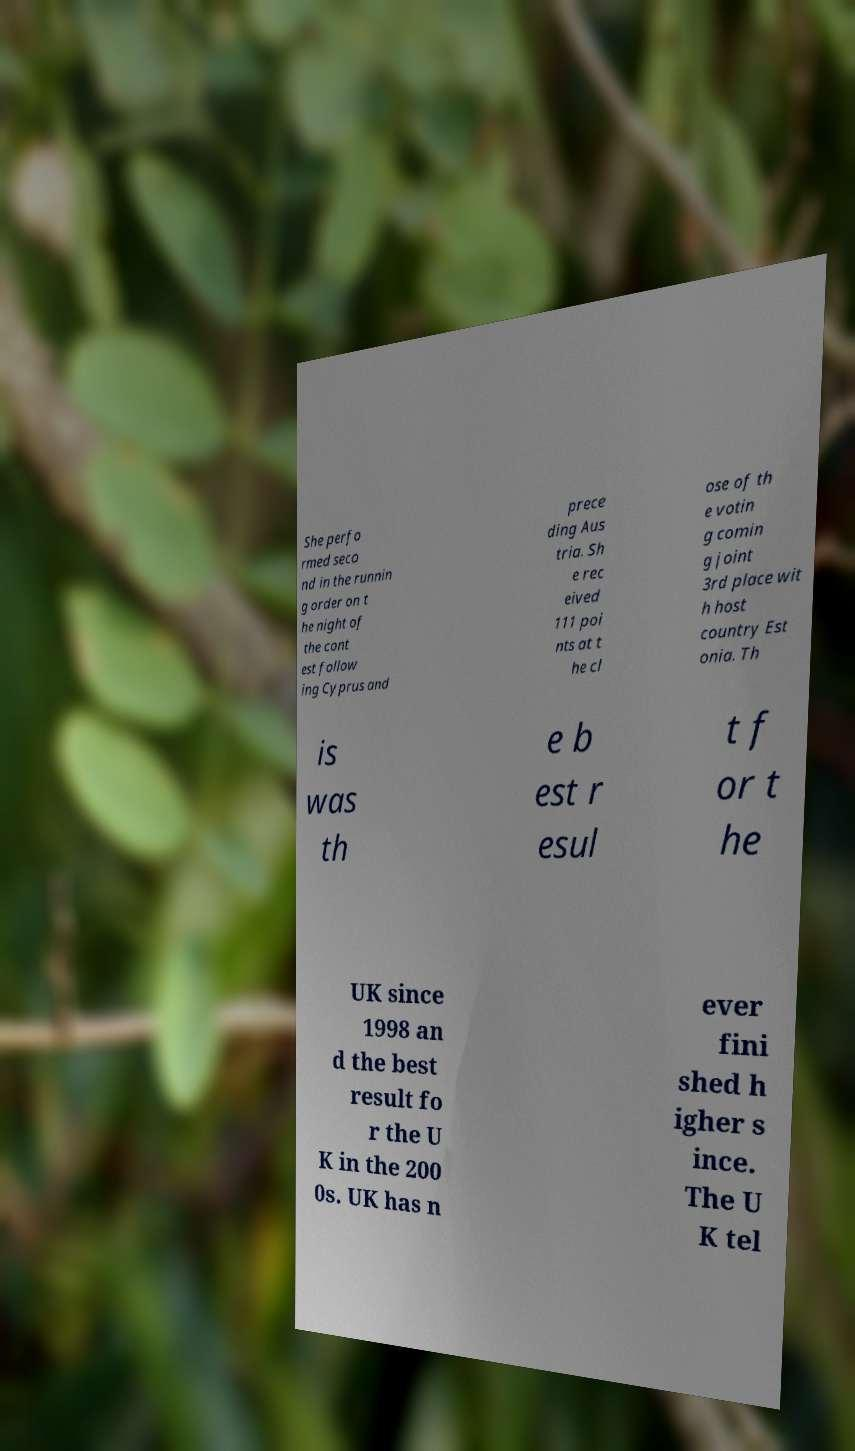Can you read and provide the text displayed in the image?This photo seems to have some interesting text. Can you extract and type it out for me? She perfo rmed seco nd in the runnin g order on t he night of the cont est follow ing Cyprus and prece ding Aus tria. Sh e rec eived 111 poi nts at t he cl ose of th e votin g comin g joint 3rd place wit h host country Est onia. Th is was th e b est r esul t f or t he UK since 1998 an d the best result fo r the U K in the 200 0s. UK has n ever fini shed h igher s ince. The U K tel 